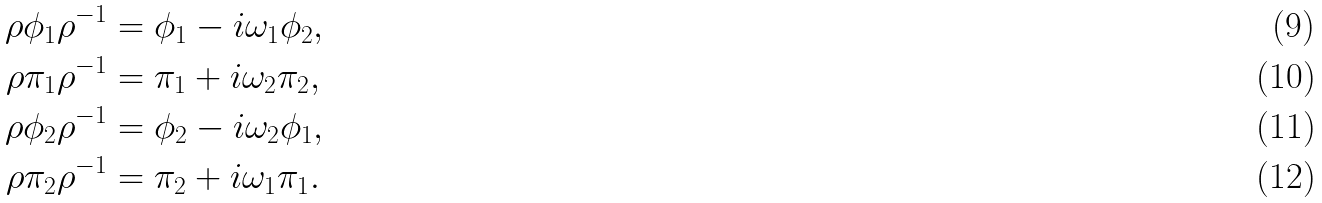<formula> <loc_0><loc_0><loc_500><loc_500>\rho \phi _ { 1 } \rho ^ { - 1 } & = \phi _ { 1 } - i \omega _ { 1 } \phi _ { 2 } , \\ \rho \pi _ { 1 } \rho ^ { - 1 } & = \pi _ { 1 } + i \omega _ { 2 } \pi _ { 2 } , \\ \rho \phi _ { 2 } \rho ^ { - 1 } & = \phi _ { 2 } - i \omega _ { 2 } \phi _ { 1 } , \\ \rho \pi _ { 2 } \rho ^ { - 1 } & = \pi _ { 2 } + i \omega _ { 1 } \pi _ { 1 } .</formula> 